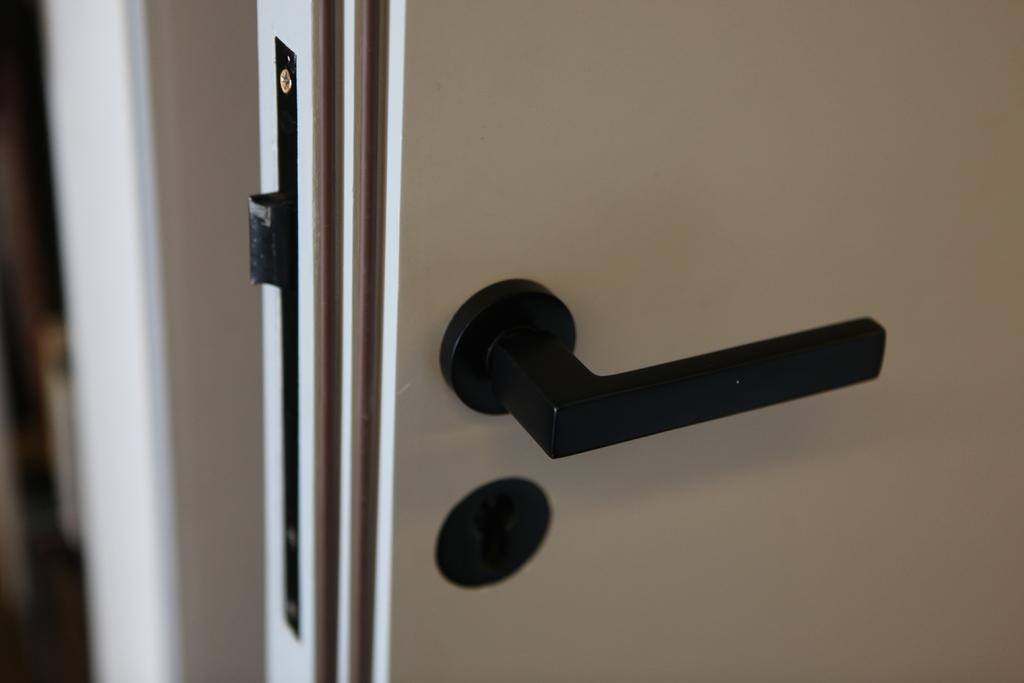What type of door is visible in the image? There is a white door in the image. What feature is present on the door? There is a door handle on the door. What is the color of the door handle? The door handle is black in color. Where is the faucet located in the image? There is no faucet present in the image. Can you tell me how many animals are visible in the zoo in the image? There is no zoo or animals present in the image. 